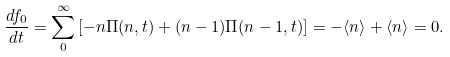Convert formula to latex. <formula><loc_0><loc_0><loc_500><loc_500>\frac { d f _ { 0 } } { d t } = \sum _ { 0 } ^ { \infty } \left [ - n \Pi ( n , t ) + ( n - 1 ) \Pi ( n - 1 , t ) \right ] = - \langle n \rangle + \langle n \rangle = 0 .</formula> 